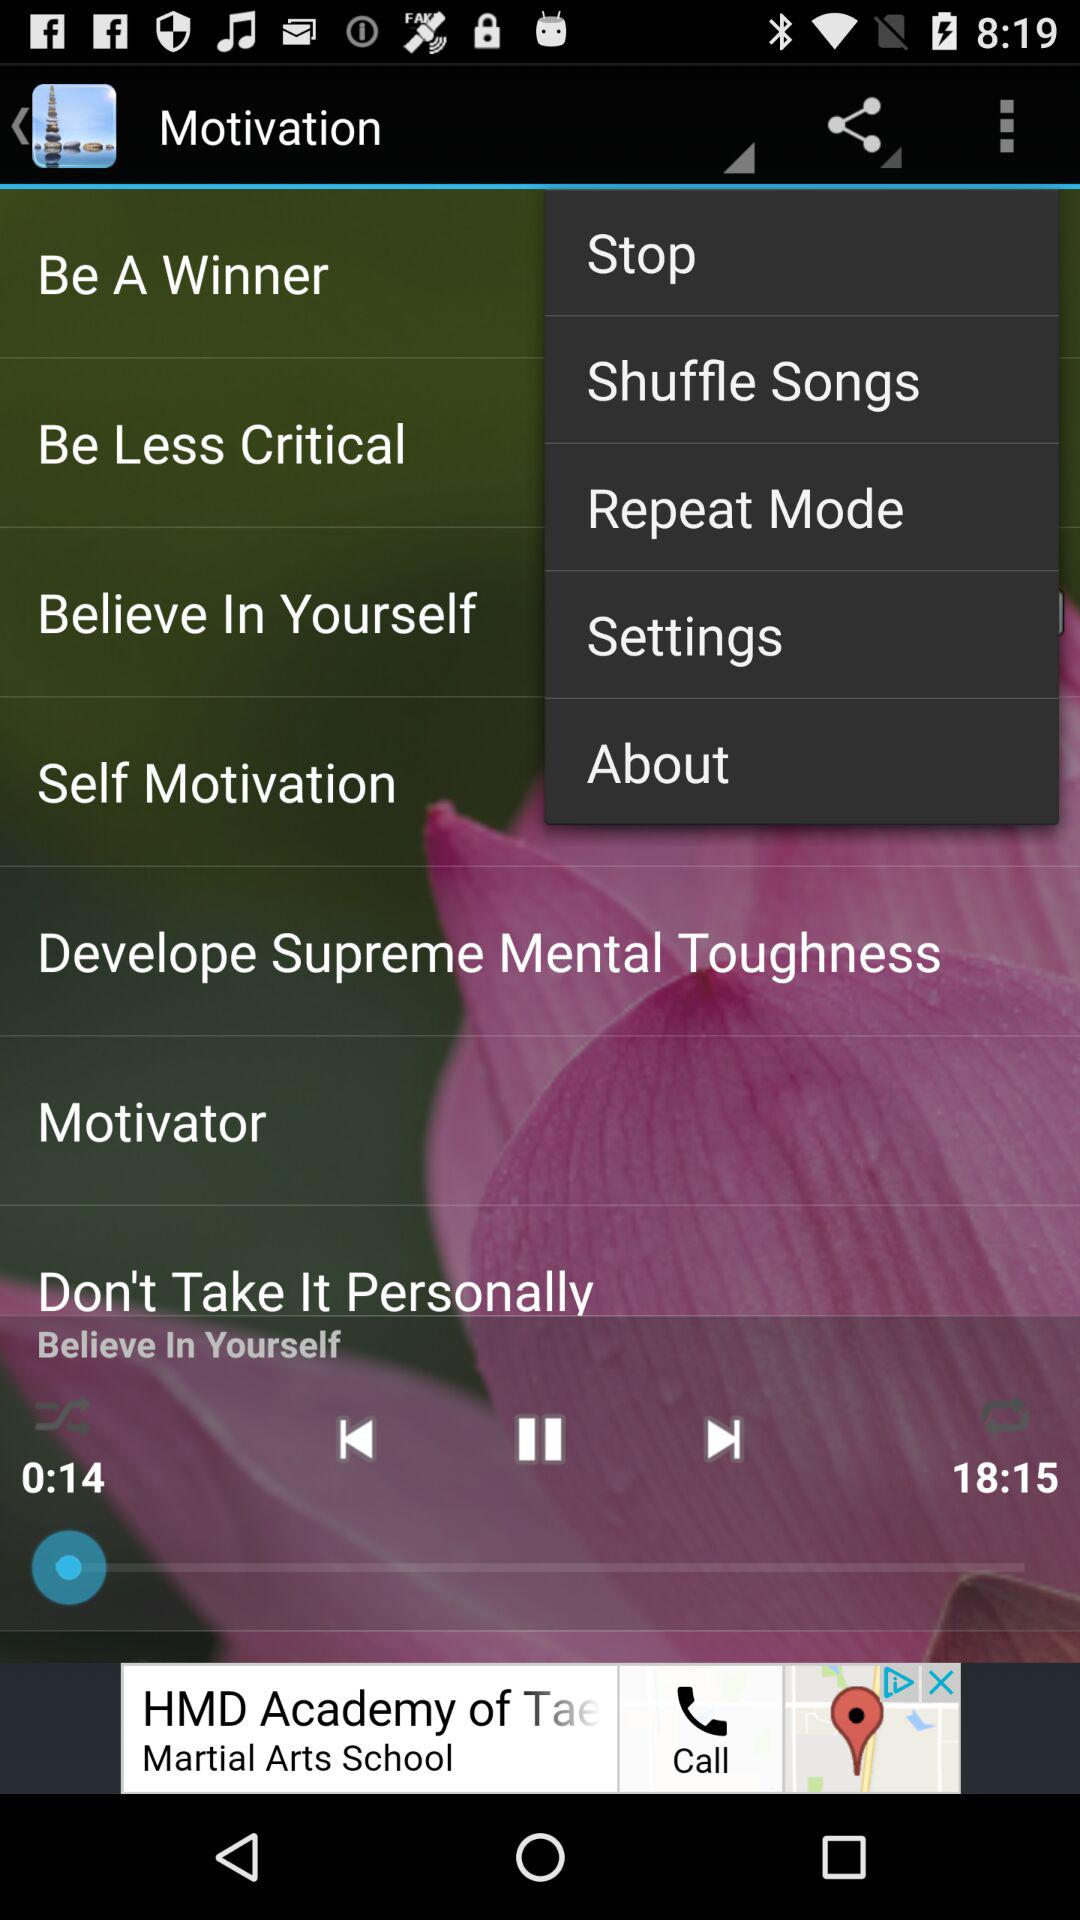What is the current time duration for the song playing in the player? The current time duration is 0:14. 